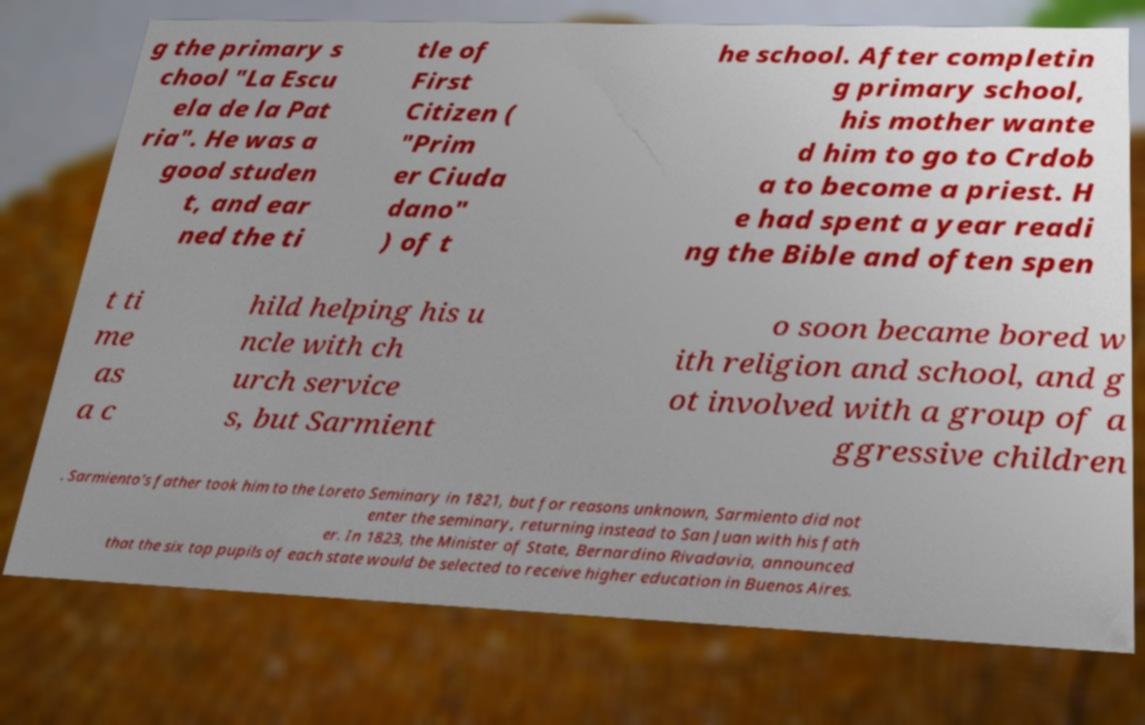I need the written content from this picture converted into text. Can you do that? g the primary s chool "La Escu ela de la Pat ria". He was a good studen t, and ear ned the ti tle of First Citizen ( "Prim er Ciuda dano" ) of t he school. After completin g primary school, his mother wante d him to go to Crdob a to become a priest. H e had spent a year readi ng the Bible and often spen t ti me as a c hild helping his u ncle with ch urch service s, but Sarmient o soon became bored w ith religion and school, and g ot involved with a group of a ggressive children . Sarmiento's father took him to the Loreto Seminary in 1821, but for reasons unknown, Sarmiento did not enter the seminary, returning instead to San Juan with his fath er. In 1823, the Minister of State, Bernardino Rivadavia, announced that the six top pupils of each state would be selected to receive higher education in Buenos Aires. 